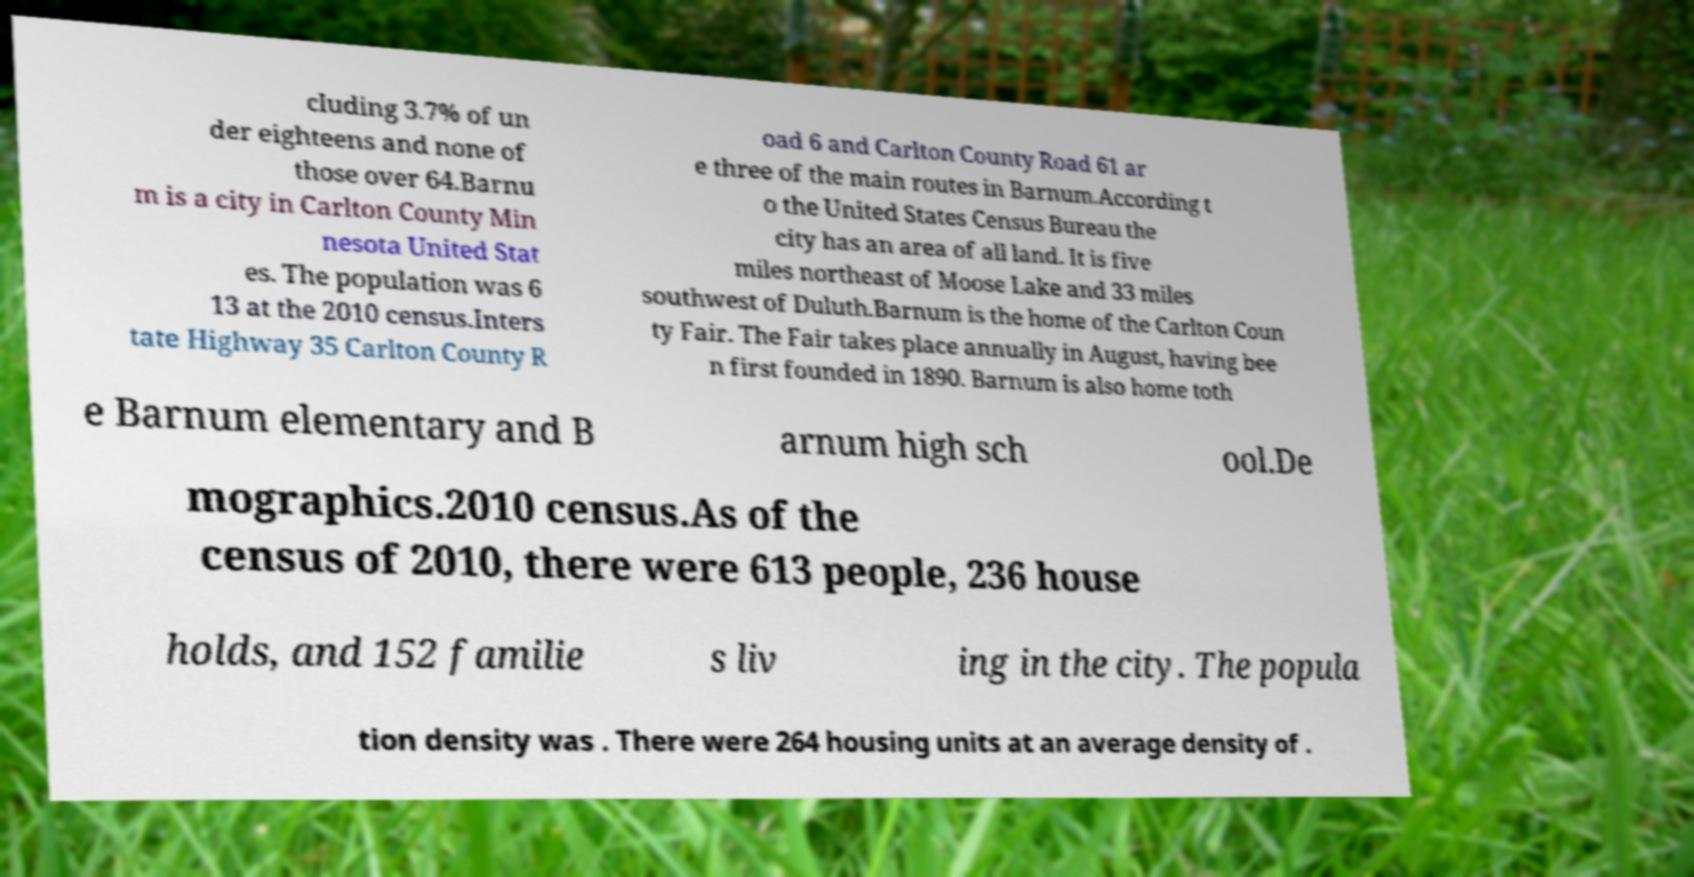I need the written content from this picture converted into text. Can you do that? cluding 3.7% of un der eighteens and none of those over 64.Barnu m is a city in Carlton County Min nesota United Stat es. The population was 6 13 at the 2010 census.Inters tate Highway 35 Carlton County R oad 6 and Carlton County Road 61 ar e three of the main routes in Barnum.According t o the United States Census Bureau the city has an area of all land. It is five miles northeast of Moose Lake and 33 miles southwest of Duluth.Barnum is the home of the Carlton Coun ty Fair. The Fair takes place annually in August, having bee n first founded in 1890. Barnum is also home toth e Barnum elementary and B arnum high sch ool.De mographics.2010 census.As of the census of 2010, there were 613 people, 236 house holds, and 152 familie s liv ing in the city. The popula tion density was . There were 264 housing units at an average density of . 